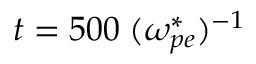<formula> <loc_0><loc_0><loc_500><loc_500>t = 5 0 0 \, ( \omega _ { p e } ^ { * } ) ^ { - 1 }</formula> 